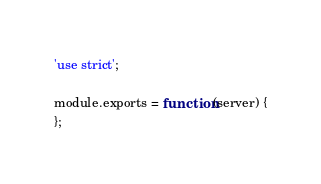Convert code to text. <code><loc_0><loc_0><loc_500><loc_500><_JavaScript_>'use strict';

module.exports = function(server) {
};

</code> 